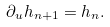Convert formula to latex. <formula><loc_0><loc_0><loc_500><loc_500>\partial _ { u } h _ { n + 1 } = h _ { n } .</formula> 